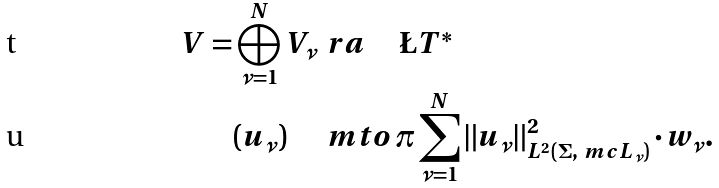Convert formula to latex. <formula><loc_0><loc_0><loc_500><loc_500>V = \bigoplus _ { \nu = 1 } ^ { N } V _ { \nu } & \, \ r a \, \quad \L T ^ { * } \\ \left ( u _ { \nu } \right ) \quad & \, \ m t o \, \pi \sum _ { \nu = 1 } ^ { N } \left \| u _ { \nu } \right \| ^ { 2 } _ { L ^ { 2 } ( \Sigma , \ m c L _ { \nu } ) } \cdot w _ { \nu } .</formula> 